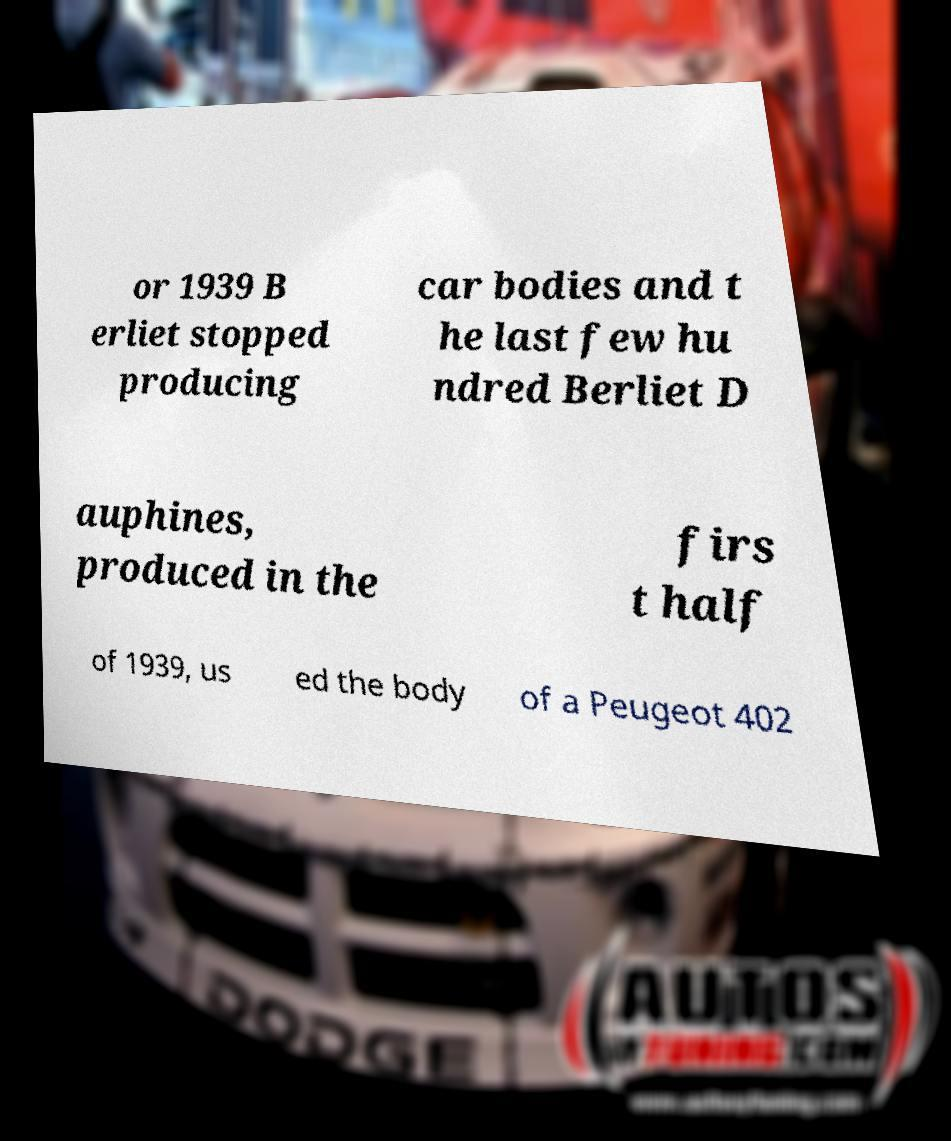For documentation purposes, I need the text within this image transcribed. Could you provide that? or 1939 B erliet stopped producing car bodies and t he last few hu ndred Berliet D auphines, produced in the firs t half of 1939, us ed the body of a Peugeot 402 